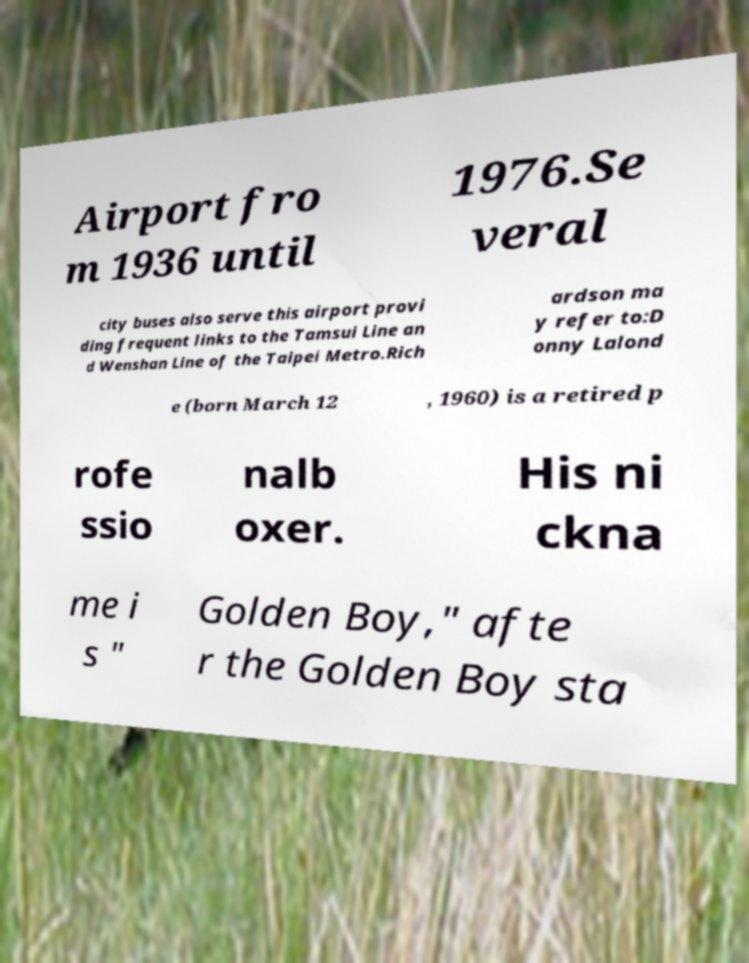Can you accurately transcribe the text from the provided image for me? Airport fro m 1936 until 1976.Se veral city buses also serve this airport provi ding frequent links to the Tamsui Line an d Wenshan Line of the Taipei Metro.Rich ardson ma y refer to:D onny Lalond e (born March 12 , 1960) is a retired p rofe ssio nalb oxer. His ni ckna me i s " Golden Boy," afte r the Golden Boy sta 